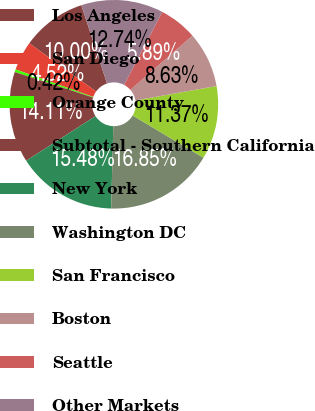Convert chart to OTSL. <chart><loc_0><loc_0><loc_500><loc_500><pie_chart><fcel>Los Angeles<fcel>San Diego<fcel>Orange County<fcel>Subtotal - Southern California<fcel>New York<fcel>Washington DC<fcel>San Francisco<fcel>Boston<fcel>Seattle<fcel>Other Markets<nl><fcel>10.0%<fcel>4.52%<fcel>0.42%<fcel>14.11%<fcel>15.48%<fcel>16.85%<fcel>11.37%<fcel>8.63%<fcel>5.89%<fcel>12.74%<nl></chart> 